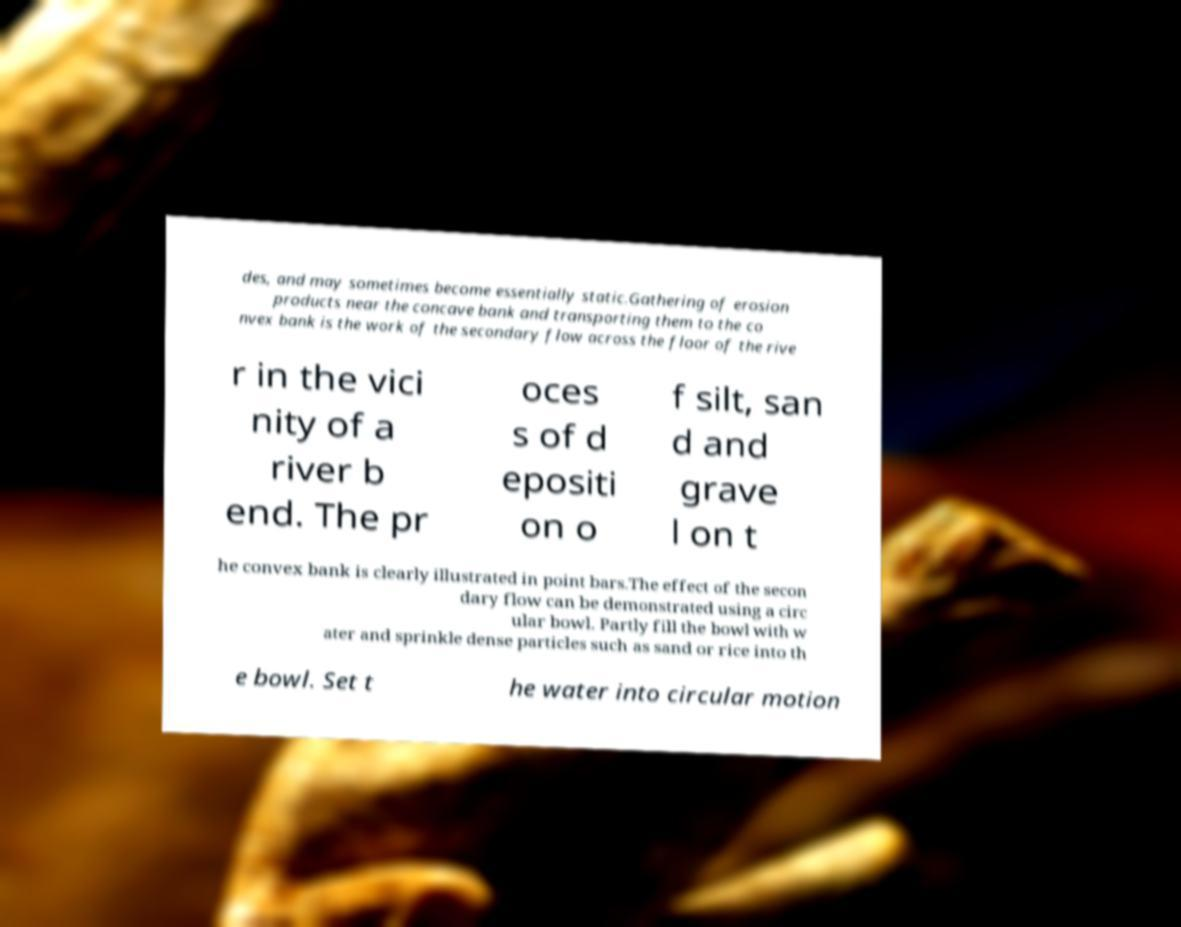There's text embedded in this image that I need extracted. Can you transcribe it verbatim? des, and may sometimes become essentially static.Gathering of erosion products near the concave bank and transporting them to the co nvex bank is the work of the secondary flow across the floor of the rive r in the vici nity of a river b end. The pr oces s of d epositi on o f silt, san d and grave l on t he convex bank is clearly illustrated in point bars.The effect of the secon dary flow can be demonstrated using a circ ular bowl. Partly fill the bowl with w ater and sprinkle dense particles such as sand or rice into th e bowl. Set t he water into circular motion 